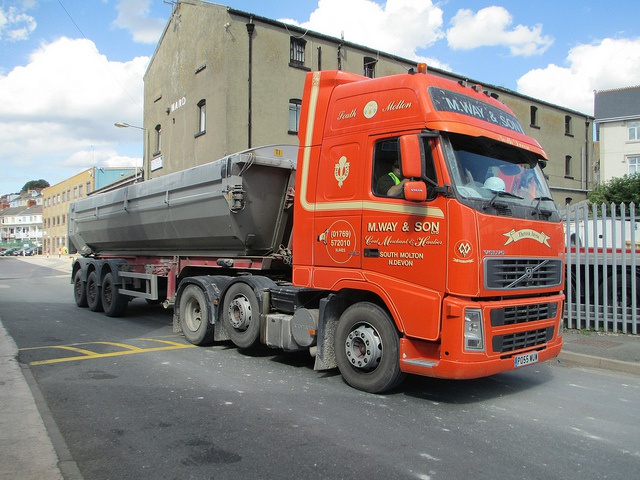Describe the objects in this image and their specific colors. I can see truck in lightblue, gray, black, and red tones, people in lightblue, black, gray, and darkgreen tones, car in lightblue, gray, darkgray, and purple tones, and car in lightblue, darkgray, and gray tones in this image. 